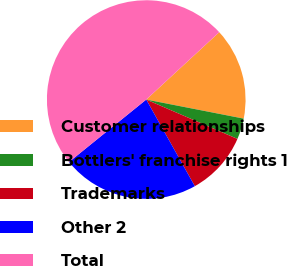Convert chart to OTSL. <chart><loc_0><loc_0><loc_500><loc_500><pie_chart><fcel>Customer relationships<fcel>Bottlers' franchise rights 1<fcel>Trademarks<fcel>Other 2<fcel>Total<nl><fcel>14.94%<fcel>3.41%<fcel>10.38%<fcel>22.31%<fcel>48.96%<nl></chart> 